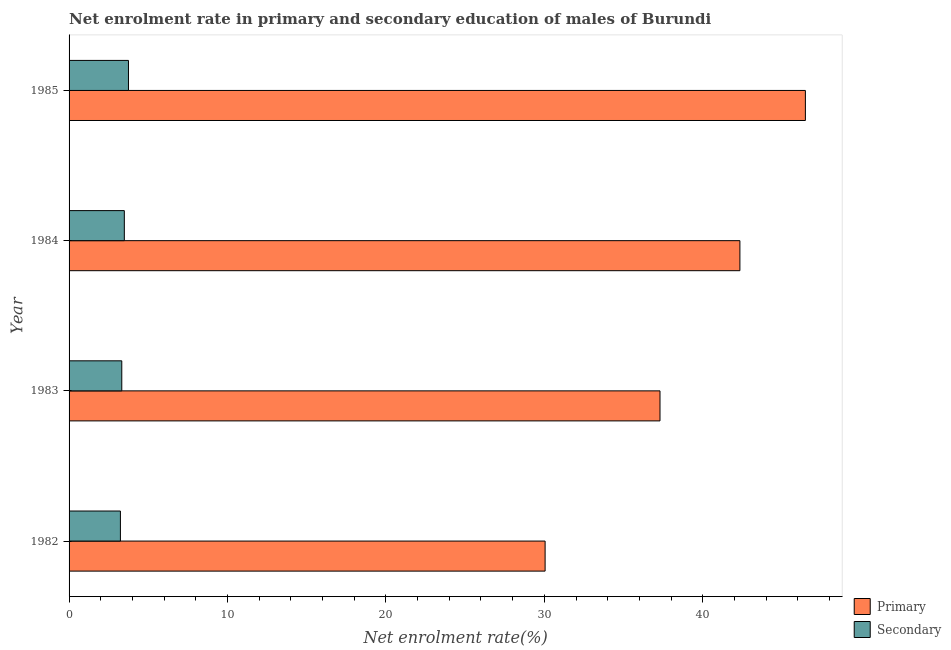How many groups of bars are there?
Offer a very short reply. 4. Are the number of bars per tick equal to the number of legend labels?
Make the answer very short. Yes. How many bars are there on the 1st tick from the top?
Your answer should be very brief. 2. What is the label of the 3rd group of bars from the top?
Keep it short and to the point. 1983. What is the enrollment rate in primary education in 1985?
Provide a short and direct response. 46.48. Across all years, what is the maximum enrollment rate in primary education?
Ensure brevity in your answer.  46.48. Across all years, what is the minimum enrollment rate in primary education?
Your answer should be very brief. 30.05. What is the total enrollment rate in primary education in the graph?
Offer a very short reply. 156.18. What is the difference between the enrollment rate in primary education in 1982 and that in 1985?
Your answer should be very brief. -16.43. What is the difference between the enrollment rate in primary education in 1985 and the enrollment rate in secondary education in 1982?
Make the answer very short. 43.24. What is the average enrollment rate in secondary education per year?
Make the answer very short. 3.45. In the year 1983, what is the difference between the enrollment rate in secondary education and enrollment rate in primary education?
Keep it short and to the point. -33.98. What is the ratio of the enrollment rate in primary education in 1983 to that in 1984?
Offer a terse response. 0.88. Is the enrollment rate in secondary education in 1983 less than that in 1985?
Give a very brief answer. Yes. Is the difference between the enrollment rate in primary education in 1983 and 1984 greater than the difference between the enrollment rate in secondary education in 1983 and 1984?
Provide a succinct answer. No. What is the difference between the highest and the second highest enrollment rate in secondary education?
Your answer should be very brief. 0.26. What is the difference between the highest and the lowest enrollment rate in primary education?
Your response must be concise. 16.43. In how many years, is the enrollment rate in secondary education greater than the average enrollment rate in secondary education taken over all years?
Your answer should be very brief. 2. Is the sum of the enrollment rate in secondary education in 1982 and 1985 greater than the maximum enrollment rate in primary education across all years?
Your answer should be very brief. No. What does the 1st bar from the top in 1985 represents?
Your response must be concise. Secondary. What does the 1st bar from the bottom in 1985 represents?
Make the answer very short. Primary. How many bars are there?
Provide a short and direct response. 8. Are the values on the major ticks of X-axis written in scientific E-notation?
Keep it short and to the point. No. Does the graph contain any zero values?
Offer a terse response. No. Does the graph contain grids?
Your answer should be very brief. No. How many legend labels are there?
Make the answer very short. 2. What is the title of the graph?
Your answer should be very brief. Net enrolment rate in primary and secondary education of males of Burundi. Does "Young" appear as one of the legend labels in the graph?
Ensure brevity in your answer.  No. What is the label or title of the X-axis?
Provide a short and direct response. Net enrolment rate(%). What is the Net enrolment rate(%) of Primary in 1982?
Give a very brief answer. 30.05. What is the Net enrolment rate(%) of Secondary in 1982?
Ensure brevity in your answer.  3.24. What is the Net enrolment rate(%) of Primary in 1983?
Ensure brevity in your answer.  37.3. What is the Net enrolment rate(%) in Secondary in 1983?
Your response must be concise. 3.33. What is the Net enrolment rate(%) in Primary in 1984?
Ensure brevity in your answer.  42.35. What is the Net enrolment rate(%) of Secondary in 1984?
Your answer should be very brief. 3.49. What is the Net enrolment rate(%) of Primary in 1985?
Provide a succinct answer. 46.48. What is the Net enrolment rate(%) of Secondary in 1985?
Offer a very short reply. 3.75. Across all years, what is the maximum Net enrolment rate(%) in Primary?
Your answer should be very brief. 46.48. Across all years, what is the maximum Net enrolment rate(%) in Secondary?
Make the answer very short. 3.75. Across all years, what is the minimum Net enrolment rate(%) in Primary?
Your answer should be very brief. 30.05. Across all years, what is the minimum Net enrolment rate(%) of Secondary?
Your response must be concise. 3.24. What is the total Net enrolment rate(%) in Primary in the graph?
Provide a short and direct response. 156.18. What is the total Net enrolment rate(%) of Secondary in the graph?
Provide a short and direct response. 13.81. What is the difference between the Net enrolment rate(%) in Primary in 1982 and that in 1983?
Your response must be concise. -7.25. What is the difference between the Net enrolment rate(%) of Secondary in 1982 and that in 1983?
Offer a very short reply. -0.09. What is the difference between the Net enrolment rate(%) in Primary in 1982 and that in 1984?
Make the answer very short. -12.3. What is the difference between the Net enrolment rate(%) of Secondary in 1982 and that in 1984?
Your answer should be compact. -0.25. What is the difference between the Net enrolment rate(%) in Primary in 1982 and that in 1985?
Provide a short and direct response. -16.43. What is the difference between the Net enrolment rate(%) in Secondary in 1982 and that in 1985?
Ensure brevity in your answer.  -0.51. What is the difference between the Net enrolment rate(%) in Primary in 1983 and that in 1984?
Provide a short and direct response. -5.04. What is the difference between the Net enrolment rate(%) of Secondary in 1983 and that in 1984?
Provide a short and direct response. -0.16. What is the difference between the Net enrolment rate(%) in Primary in 1983 and that in 1985?
Ensure brevity in your answer.  -9.18. What is the difference between the Net enrolment rate(%) in Secondary in 1983 and that in 1985?
Provide a short and direct response. -0.42. What is the difference between the Net enrolment rate(%) of Primary in 1984 and that in 1985?
Your answer should be compact. -4.13. What is the difference between the Net enrolment rate(%) in Secondary in 1984 and that in 1985?
Provide a succinct answer. -0.26. What is the difference between the Net enrolment rate(%) in Primary in 1982 and the Net enrolment rate(%) in Secondary in 1983?
Your answer should be very brief. 26.72. What is the difference between the Net enrolment rate(%) of Primary in 1982 and the Net enrolment rate(%) of Secondary in 1984?
Keep it short and to the point. 26.56. What is the difference between the Net enrolment rate(%) in Primary in 1982 and the Net enrolment rate(%) in Secondary in 1985?
Make the answer very short. 26.3. What is the difference between the Net enrolment rate(%) of Primary in 1983 and the Net enrolment rate(%) of Secondary in 1984?
Ensure brevity in your answer.  33.81. What is the difference between the Net enrolment rate(%) in Primary in 1983 and the Net enrolment rate(%) in Secondary in 1985?
Give a very brief answer. 33.55. What is the difference between the Net enrolment rate(%) of Primary in 1984 and the Net enrolment rate(%) of Secondary in 1985?
Provide a short and direct response. 38.6. What is the average Net enrolment rate(%) in Primary per year?
Your answer should be compact. 39.04. What is the average Net enrolment rate(%) in Secondary per year?
Offer a terse response. 3.45. In the year 1982, what is the difference between the Net enrolment rate(%) of Primary and Net enrolment rate(%) of Secondary?
Give a very brief answer. 26.81. In the year 1983, what is the difference between the Net enrolment rate(%) in Primary and Net enrolment rate(%) in Secondary?
Your answer should be compact. 33.97. In the year 1984, what is the difference between the Net enrolment rate(%) in Primary and Net enrolment rate(%) in Secondary?
Keep it short and to the point. 38.86. In the year 1985, what is the difference between the Net enrolment rate(%) of Primary and Net enrolment rate(%) of Secondary?
Ensure brevity in your answer.  42.73. What is the ratio of the Net enrolment rate(%) in Primary in 1982 to that in 1983?
Offer a terse response. 0.81. What is the ratio of the Net enrolment rate(%) in Secondary in 1982 to that in 1983?
Offer a very short reply. 0.97. What is the ratio of the Net enrolment rate(%) of Primary in 1982 to that in 1984?
Your answer should be very brief. 0.71. What is the ratio of the Net enrolment rate(%) in Secondary in 1982 to that in 1984?
Make the answer very short. 0.93. What is the ratio of the Net enrolment rate(%) of Primary in 1982 to that in 1985?
Provide a short and direct response. 0.65. What is the ratio of the Net enrolment rate(%) in Secondary in 1982 to that in 1985?
Your response must be concise. 0.86. What is the ratio of the Net enrolment rate(%) of Primary in 1983 to that in 1984?
Your answer should be very brief. 0.88. What is the ratio of the Net enrolment rate(%) in Secondary in 1983 to that in 1984?
Give a very brief answer. 0.95. What is the ratio of the Net enrolment rate(%) of Primary in 1983 to that in 1985?
Give a very brief answer. 0.8. What is the ratio of the Net enrolment rate(%) of Secondary in 1983 to that in 1985?
Provide a succinct answer. 0.89. What is the ratio of the Net enrolment rate(%) in Primary in 1984 to that in 1985?
Your answer should be compact. 0.91. What is the ratio of the Net enrolment rate(%) of Secondary in 1984 to that in 1985?
Your response must be concise. 0.93. What is the difference between the highest and the second highest Net enrolment rate(%) in Primary?
Your response must be concise. 4.13. What is the difference between the highest and the second highest Net enrolment rate(%) in Secondary?
Ensure brevity in your answer.  0.26. What is the difference between the highest and the lowest Net enrolment rate(%) in Primary?
Provide a short and direct response. 16.43. What is the difference between the highest and the lowest Net enrolment rate(%) in Secondary?
Ensure brevity in your answer.  0.51. 